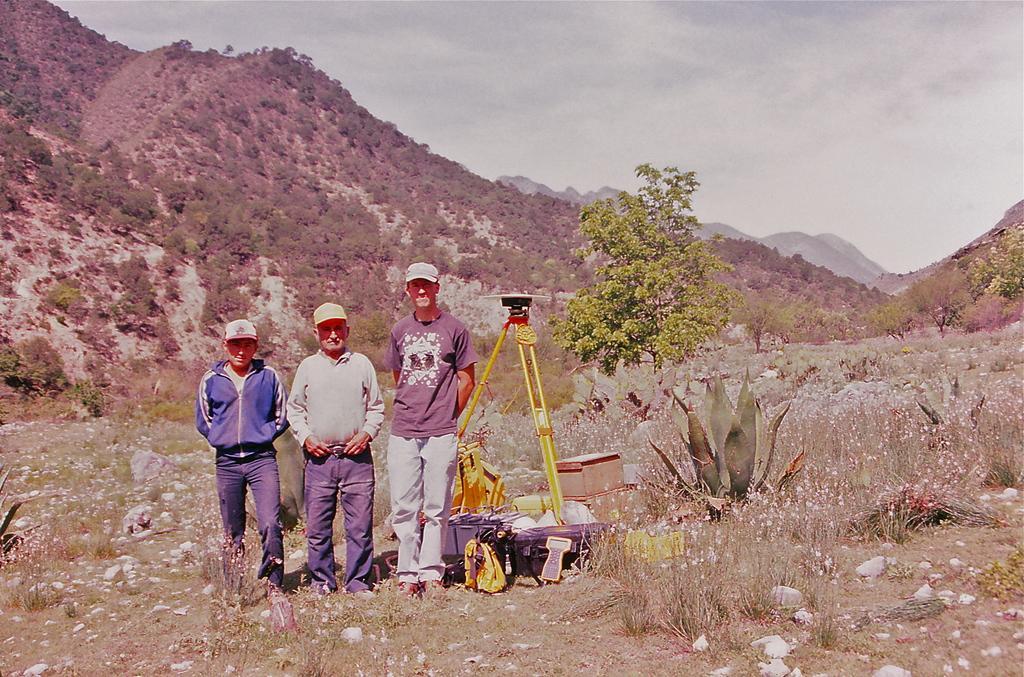Can you describe this image briefly? In this picture we can see three men standing, they wore caps, there is something present behind this person, at the bottom there are some plants and stones, in the background there are some trees, on the left side there is a hill, we can see the sky at the top of the picture, we can also see some boxes at the bottom. 